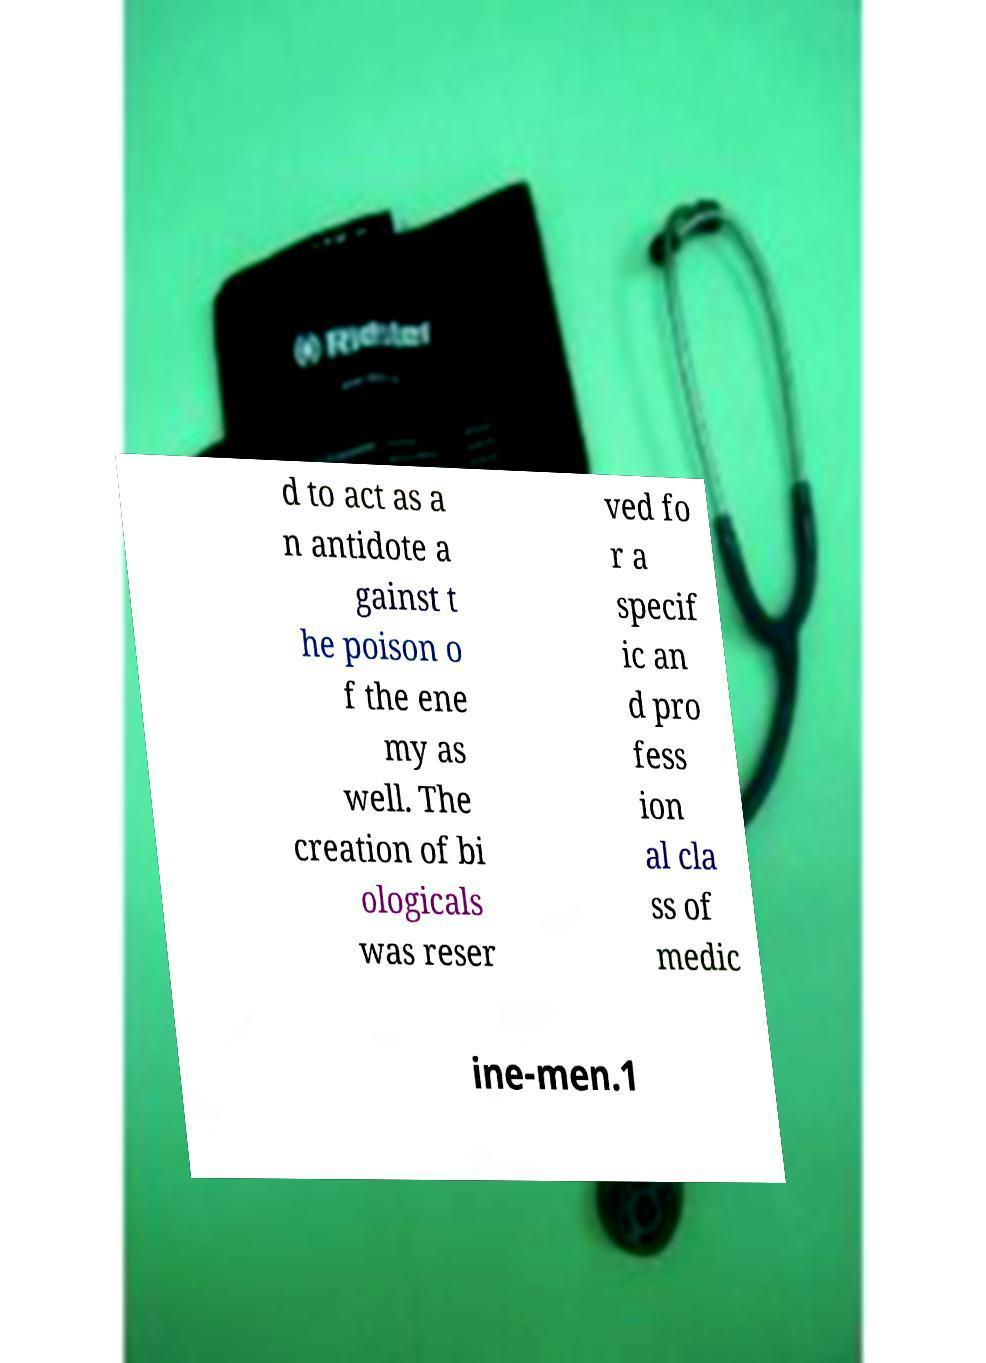For documentation purposes, I need the text within this image transcribed. Could you provide that? d to act as a n antidote a gainst t he poison o f the ene my as well. The creation of bi ologicals was reser ved fo r a specif ic an d pro fess ion al cla ss of medic ine-men.1 